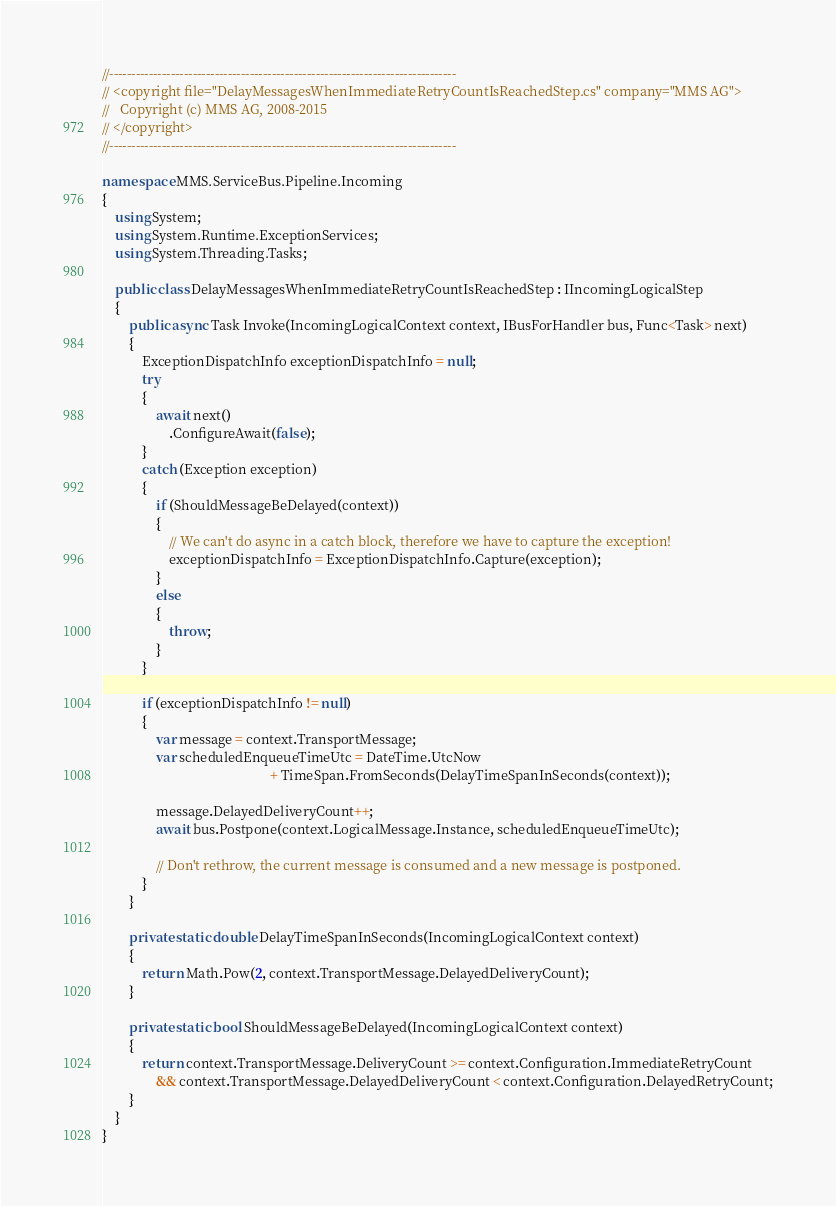<code> <loc_0><loc_0><loc_500><loc_500><_C#_>//-------------------------------------------------------------------------------
// <copyright file="DelayMessagesWhenImmediateRetryCountIsReachedStep.cs" company="MMS AG">
//   Copyright (c) MMS AG, 2008-2015
// </copyright>
//-------------------------------------------------------------------------------

namespace MMS.ServiceBus.Pipeline.Incoming
{
    using System;
    using System.Runtime.ExceptionServices;
    using System.Threading.Tasks;

    public class DelayMessagesWhenImmediateRetryCountIsReachedStep : IIncomingLogicalStep
    {
        public async Task Invoke(IncomingLogicalContext context, IBusForHandler bus, Func<Task> next)
        {
            ExceptionDispatchInfo exceptionDispatchInfo = null;
            try
            {
                await next()
                    .ConfigureAwait(false);
            }
            catch (Exception exception)
            {
                if (ShouldMessageBeDelayed(context))
                {
                    // We can't do async in a catch block, therefore we have to capture the exception!
                    exceptionDispatchInfo = ExceptionDispatchInfo.Capture(exception);
                }
                else
                {
                    throw;
                }
            }

            if (exceptionDispatchInfo != null)
            {
                var message = context.TransportMessage;
                var scheduledEnqueueTimeUtc = DateTime.UtcNow
                                                  + TimeSpan.FromSeconds(DelayTimeSpanInSeconds(context));

                message.DelayedDeliveryCount++;
                await bus.Postpone(context.LogicalMessage.Instance, scheduledEnqueueTimeUtc);

                // Don't rethrow, the current message is consumed and a new message is postponed.
            }
        }

        private static double DelayTimeSpanInSeconds(IncomingLogicalContext context)
        {
            return Math.Pow(2, context.TransportMessage.DelayedDeliveryCount);
        }

        private static bool ShouldMessageBeDelayed(IncomingLogicalContext context)
        {
            return context.TransportMessage.DeliveryCount >= context.Configuration.ImmediateRetryCount 
                && context.TransportMessage.DelayedDeliveryCount < context.Configuration.DelayedRetryCount;
        }
    }
}</code> 